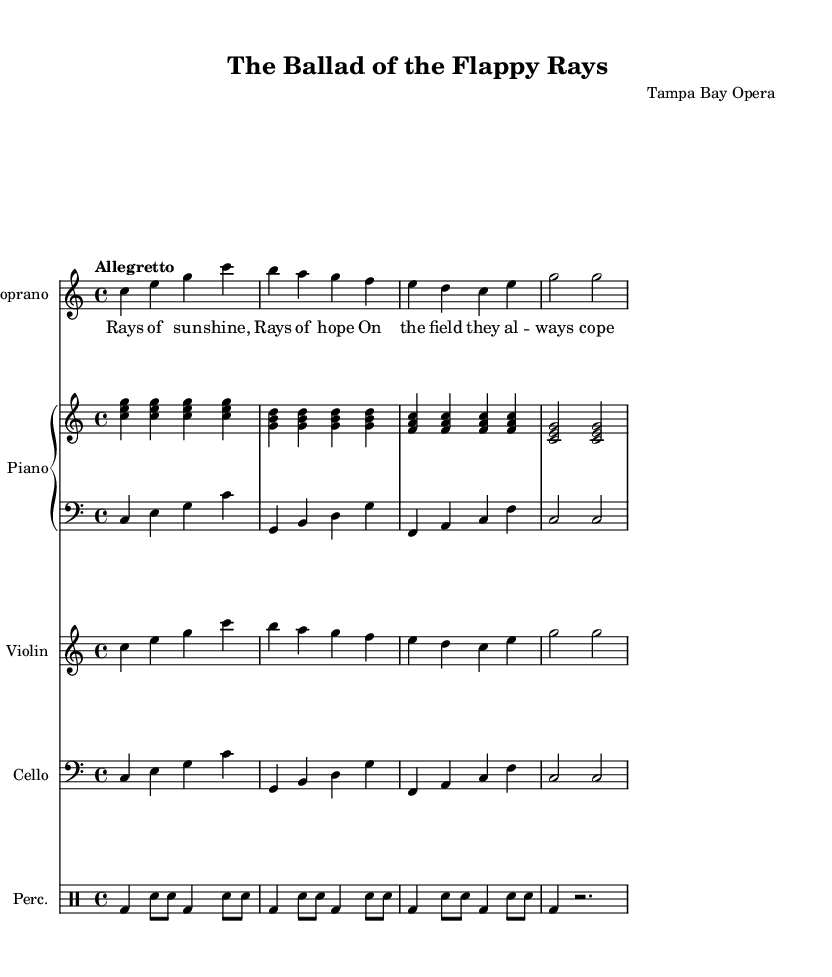What is the key signature of this music? The key signature is indicated by the absence of any sharps or flats, which shows that it is in C major.
Answer: C major What is the time signature of this piece? The time signature is displayed at the beginning of the score, which indicates four beats per measure.
Answer: 4/4 What is the tempo marking for this opera? The tempo marking is provided just above the musical staff, indicating the piece should be played at a moderate speed.
Answer: Allegretto How many measures are in the soprano line? By counting the distinct groupings of notes and rests in the soprano line, it is clear that there are eight measures.
Answer: 8 What dynamics are indicated in the soprano part? The soprano part starts with a dynamic marking indicating to play with a specific intensity, which is not detailed here but can typically be noted as "dynamic up," indicating expressive singing.
Answer: dynamic up What is the main theme of the lyrics in this opera? The lyrics describe emotions related to baseball and excitement on the field, highlighting the team's spirit and hope, which is a central theme in this comedic opera piece.
Answer: Rays of sun -- shine, Rays of hope What instruments are included in the score? The score includes parts for soprano, piano (both right and left hand), violin, cello, and percussion, showing a diverse orchestration typical of operas.
Answer: Soprano, Piano, Violin, Cello, Percussion 